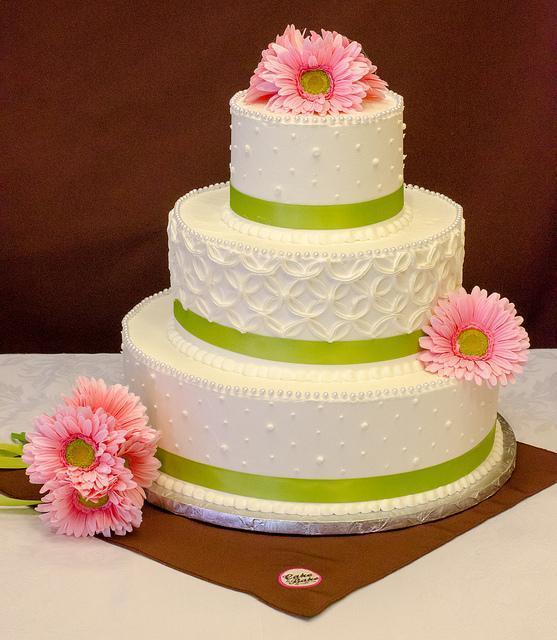Evaluate: Does the caption "The cake is at the edge of the dining table." match the image?
Answer yes or no. No. 